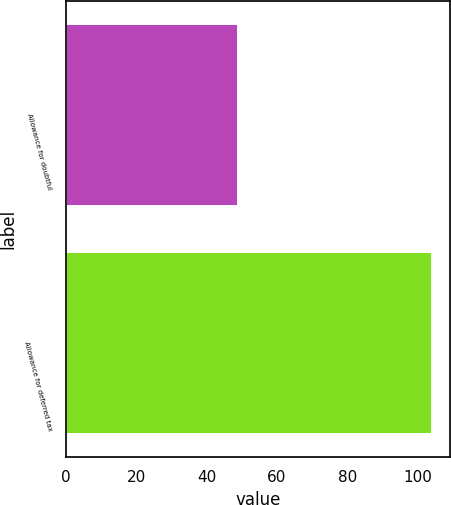<chart> <loc_0><loc_0><loc_500><loc_500><bar_chart><fcel>Allowance for doubtful<fcel>Allowance for deferred tax<nl><fcel>49<fcel>104<nl></chart> 